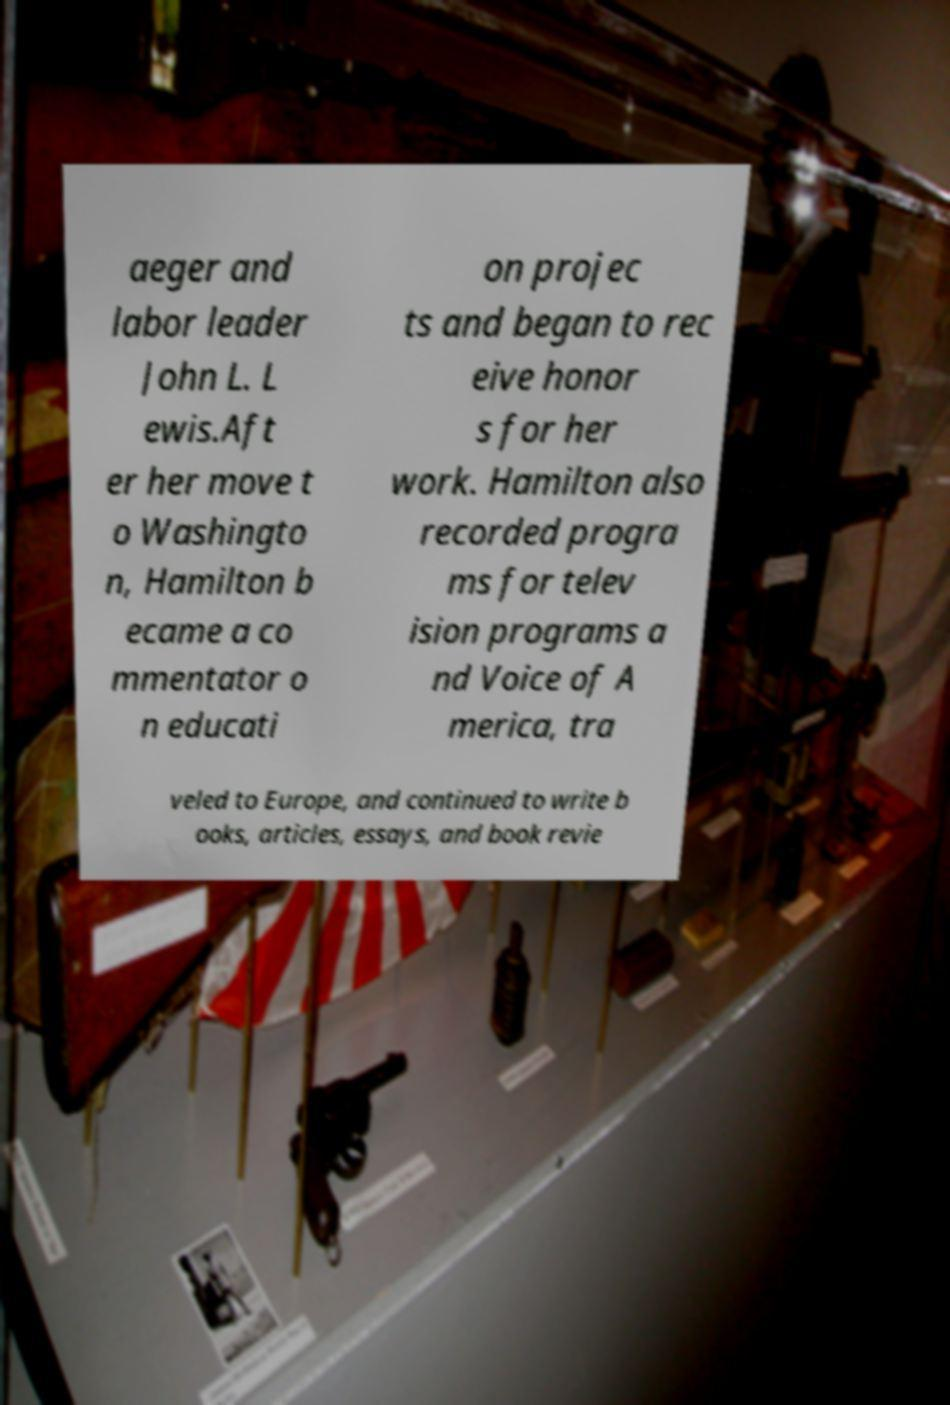Please read and relay the text visible in this image. What does it say? aeger and labor leader John L. L ewis.Aft er her move t o Washingto n, Hamilton b ecame a co mmentator o n educati on projec ts and began to rec eive honor s for her work. Hamilton also recorded progra ms for telev ision programs a nd Voice of A merica, tra veled to Europe, and continued to write b ooks, articles, essays, and book revie 